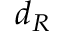<formula> <loc_0><loc_0><loc_500><loc_500>d _ { R }</formula> 